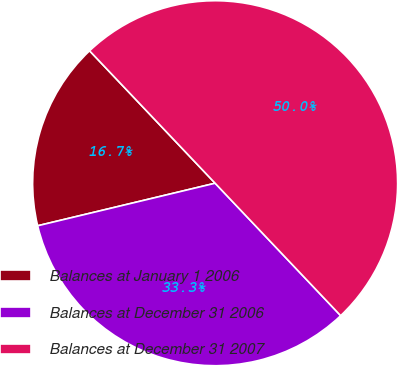Convert chart. <chart><loc_0><loc_0><loc_500><loc_500><pie_chart><fcel>Balances at January 1 2006<fcel>Balances at December 31 2006<fcel>Balances at December 31 2007<nl><fcel>16.67%<fcel>33.33%<fcel>50.0%<nl></chart> 